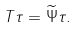Convert formula to latex. <formula><loc_0><loc_0><loc_500><loc_500>T \tau = \widetilde { \Psi } \tau .</formula> 